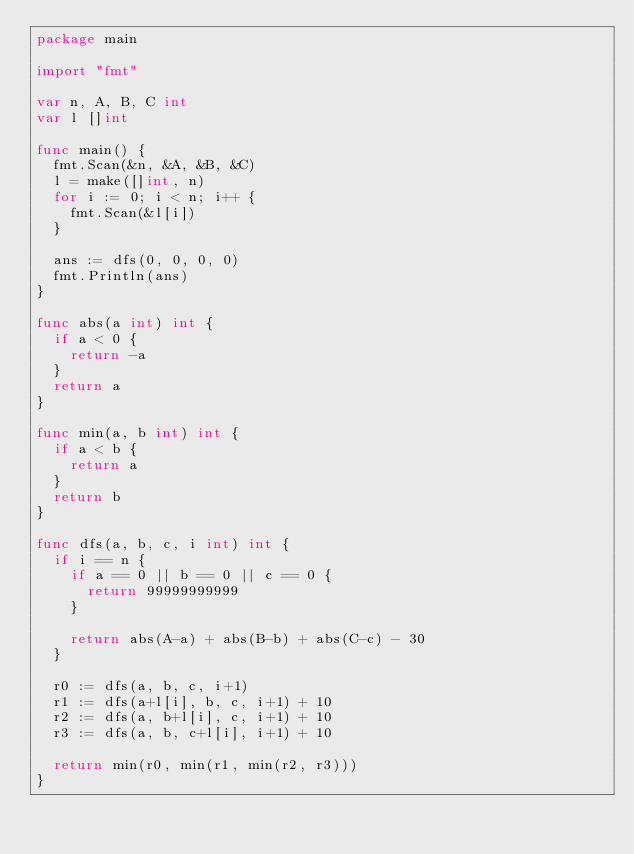<code> <loc_0><loc_0><loc_500><loc_500><_Go_>package main

import "fmt"

var n, A, B, C int
var l []int

func main() {
	fmt.Scan(&n, &A, &B, &C)
	l = make([]int, n)
	for i := 0; i < n; i++ {
		fmt.Scan(&l[i])
	}

	ans := dfs(0, 0, 0, 0)
	fmt.Println(ans)
}

func abs(a int) int {
	if a < 0 {
		return -a
	}
	return a
}

func min(a, b int) int {
	if a < b {
		return a
	}
	return b
}

func dfs(a, b, c, i int) int {
	if i == n {
		if a == 0 || b == 0 || c == 0 {
			return 99999999999
		}

		return abs(A-a) + abs(B-b) + abs(C-c) - 30
	}

	r0 := dfs(a, b, c, i+1)
	r1 := dfs(a+l[i], b, c, i+1) + 10
	r2 := dfs(a, b+l[i], c, i+1) + 10
	r3 := dfs(a, b, c+l[i], i+1) + 10

	return min(r0, min(r1, min(r2, r3)))
}
</code> 